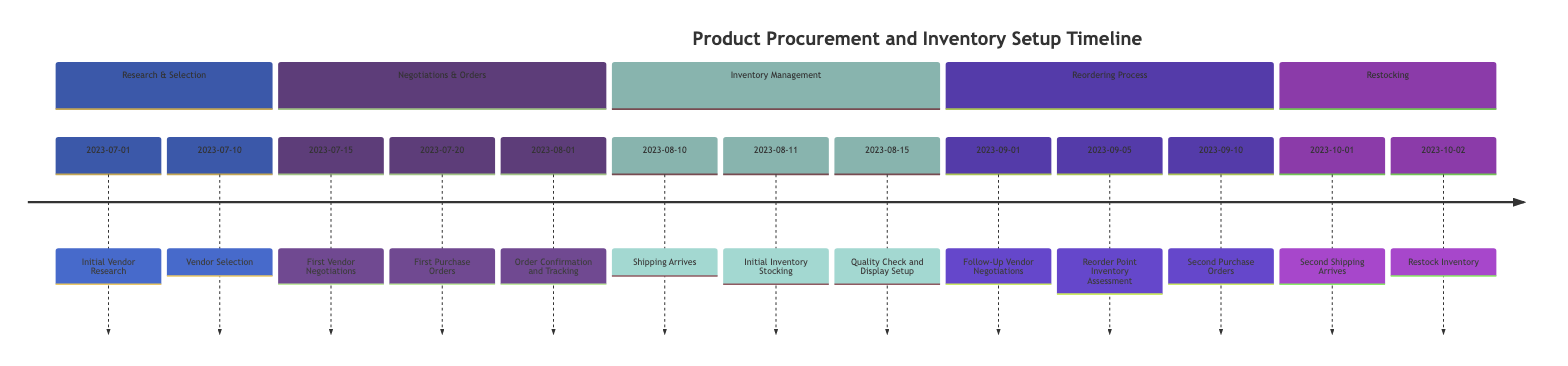What date did the initial vendor research occur? The timeline indicates that the first event, "Initial Vendor Research," is dated 2023-07-01. This is the earliest point in the timeline, confirming the date of initial vendor exploration activities.
Answer: 2023-07-01 How many vendor selections were made? The timeline mentions "Vendor Selection" on 2023-07-10. Under this event, three vendors were mentioned: 'Fashion Nova', 'Urban Outfitters', and 'Etsy Wholesale,' indicating three vendors were selected in total.
Answer: Three What event happened immediately after receiving shipping? The event "Initial Inventory Stocking" occurs the day after shipping arrival on 2023-08-10. This indicates that once the shipments arrived, the next step was to stock the boutique with the received inventory.
Answer: Initial Inventory Stocking Which event follows the first vendor negotiations? "First Purchase Orders" directly follows "First Vendor Negotiations" based on the timeline, as it is listed as the next event on 2023-07-20. This shows the sequence of activities from negotiations to order placement.
Answer: First Purchase Orders What was done on 2023-09-05? The event "Reorder Point Inventory Assessment" is scheduled on 2023-09-05, which involves evaluating inventory levels to decide on reorders. This reflects the ongoing management aspect of inventory based on recent sales.
Answer: Reorder Point Inventory Assessment How many days passed between the first shipping arrival and the initial inventory stocking? The first shipment arrived on 2023-08-10, and the initial inventory stocking occurred on 2023-08-11, indicating that only one day passed between these two events. This is calculated by counting the days on the timeline.
Answer: One day What is the final activity listed in the timeline? The last event on the timeline is "Restock Inventory," dated 2023-10-02. This indicates the final step in the timeline regarding inventory management and maintaining stock levels in the boutique.
Answer: Restock Inventory Which section of the timeline includes negotiations? The section labeled "Negotiations & Orders" encompasses the events related to vendor negotiations and the placing of purchase orders. This section clearly outlines the negotiation steps taken for vendor agreements.
Answer: Negotiations & Orders What is the gap in days between the second shipping and restocking of inventory? The second shipping arrives on 2023-10-01, and the restocking occurs the next day on 2023-10-02. Counting the days shows there is no gap as they are consecutive events.
Answer: Zero days 